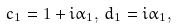<formula> <loc_0><loc_0><loc_500><loc_500>c _ { 1 } = 1 + i \alpha _ { 1 } , \, d _ { 1 } = i \alpha _ { 1 } ,</formula> 